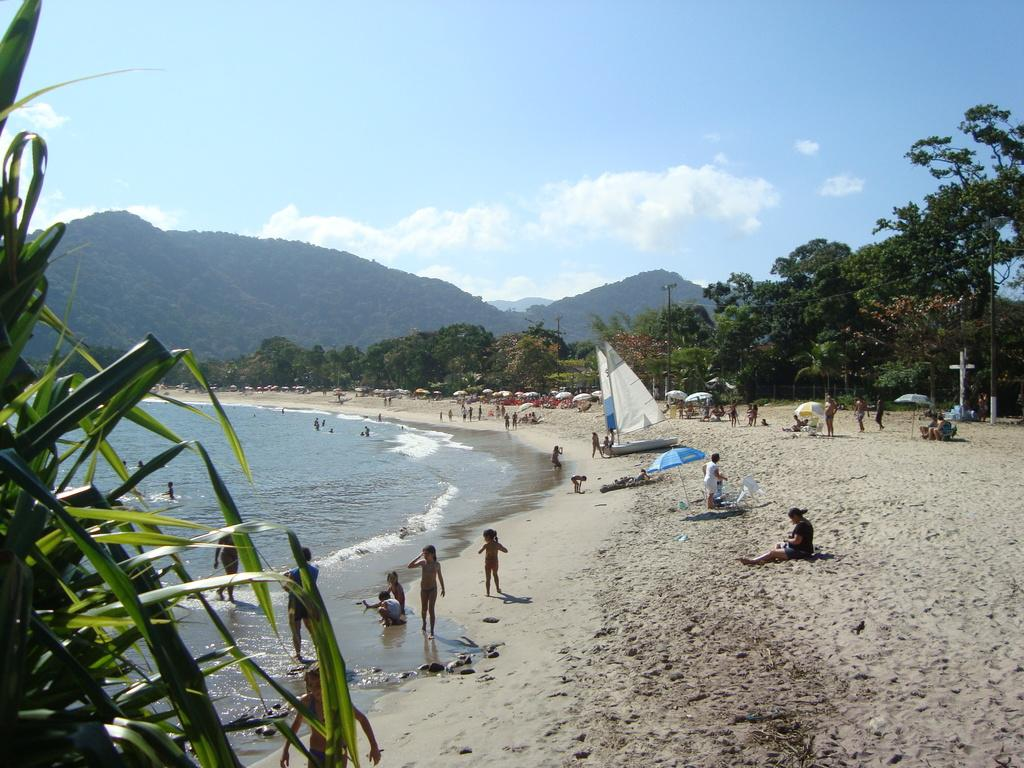What can be seen in the image involving groups of people? There are groups of people in the image. What else is present in the image besides people? There are boats, umbrellas, trees on the seashore, people in the water, hills in the background, and the sky visible in the background. What might people be using to protect themselves from the sun or rain? Umbrellas are present in the image, which people might be using for protection. What type of natural environment is visible in the image? The image features a seashore with trees and hills in the background. Can you tell me how many times the man kicks the scissors in the image? There is no man or scissors present in the image, so this action cannot be observed. 